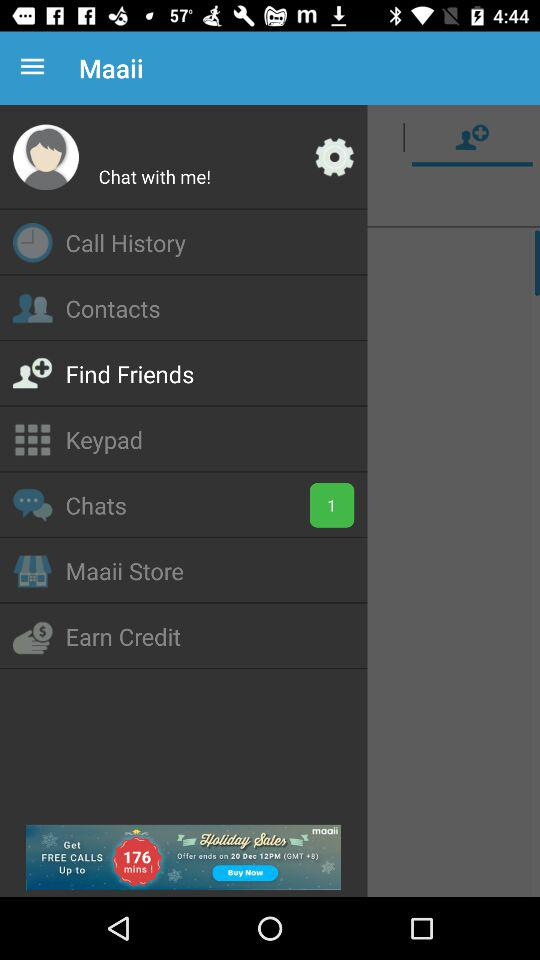How can you earn credits?
When the provided information is insufficient, respond with <no answer>. <no answer> 